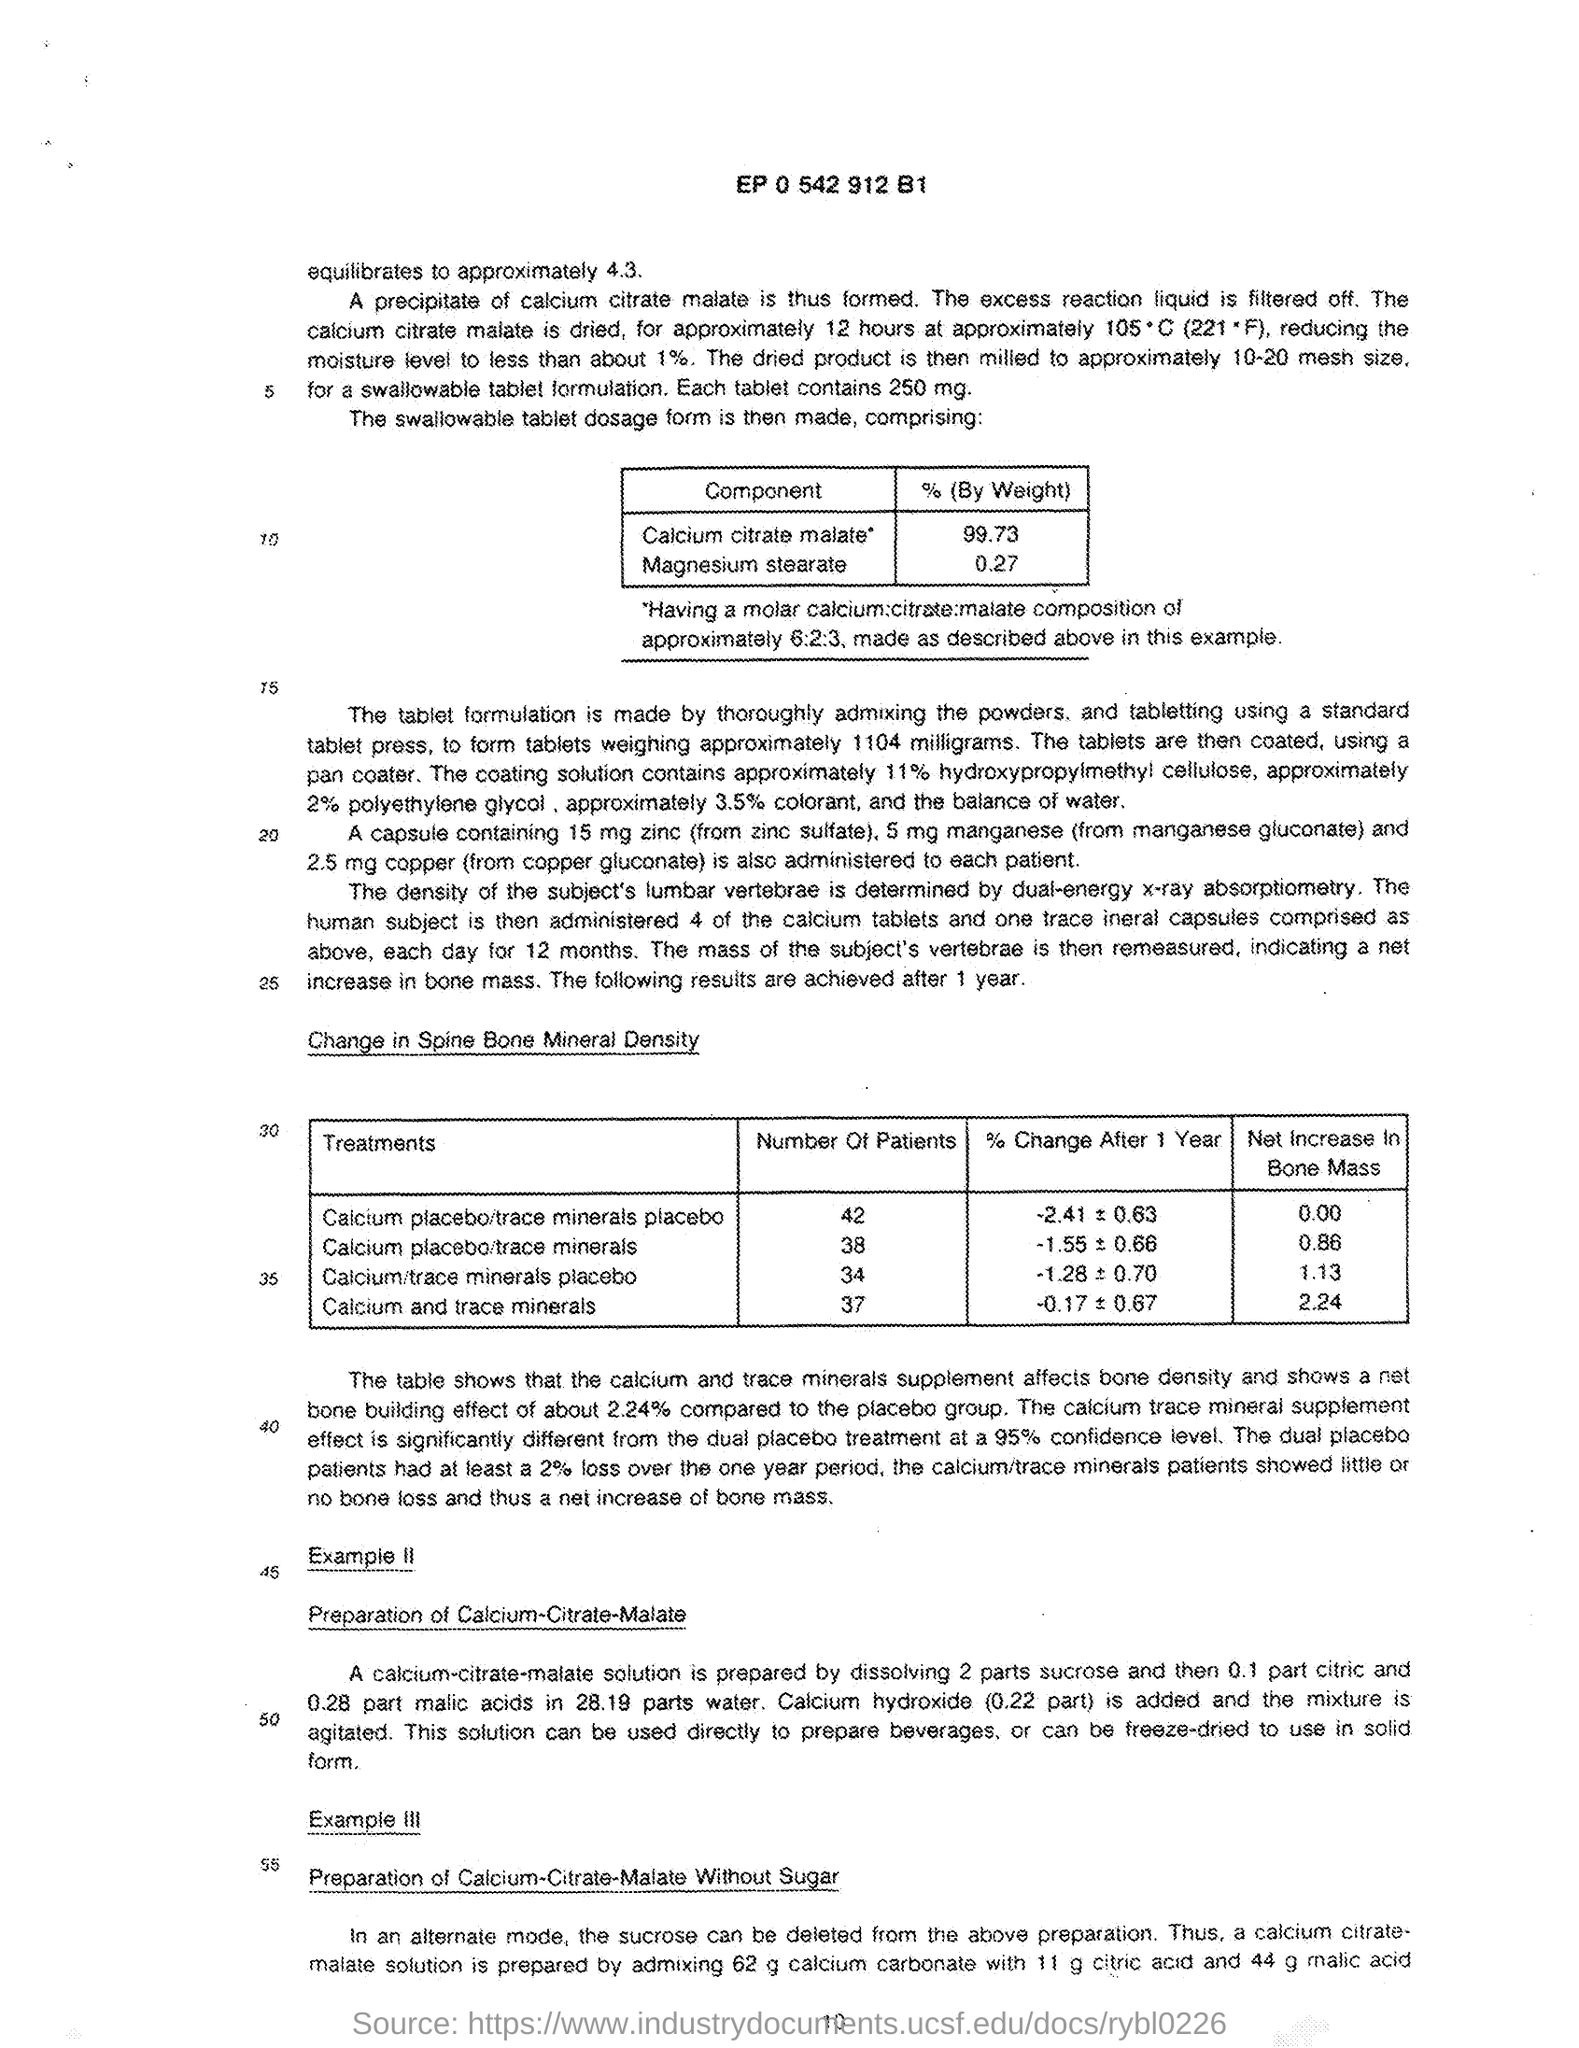List a handful of essential elements in this visual. The analysis of the sample revealed that it contains 99.73% calcium citrate malate. The percentage of Magnesium stearate is 0.27%. The number at the top of the document is EP 0 542 912 B1. The treatment of calcium and trace minerals involves a total of 37 patients. The number of patients for the treatment of "calcium/trace minerals placebo" is 34. 